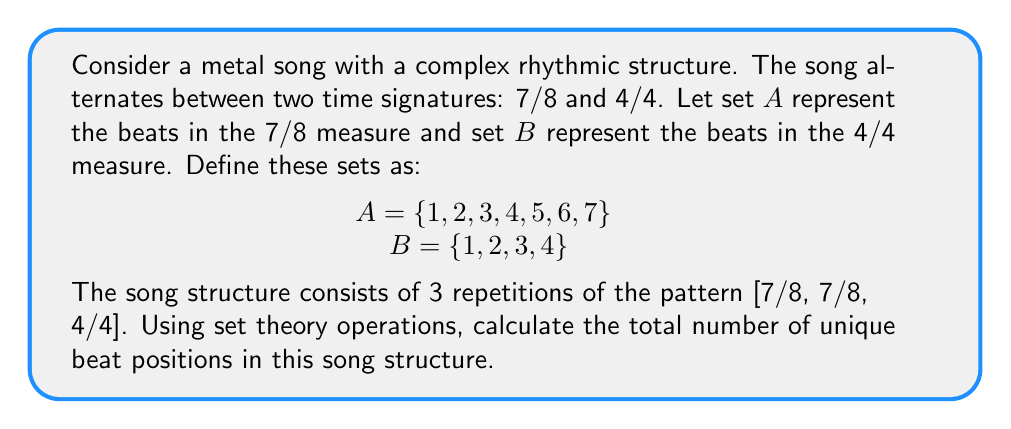Can you answer this question? To solve this problem, we need to follow these steps:

1) First, let's consider the pattern [7/8, 7/8, 4/4]. This can be represented as A ∪ A ∪ B.

2) Since A ∪ A = A (union with itself doesn't add new elements), we can simplify this to A ∪ B.

3) Now, we need to calculate |A ∪ B|, where |X| denotes the cardinality (number of elements) of set X.

4) We can use the formula: |A ∪ B| = |A| + |B| - |A ∩ B|

5) We know:
   |A| = 7
   |B| = 4
   A ∩ B = {1, 2, 3, 4}, so |A ∩ B| = 4

6) Plugging into the formula:
   |A ∪ B| = 7 + 4 - 4 = 7

7) This means there are 7 unique beat positions in one repetition of the pattern.

8) The song structure consists of 3 repetitions of this pattern.

9) Since these repetitions don't add any new unique beat positions, the total number of unique beat positions in the song structure remains 7.
Answer: The total number of unique beat positions in the song structure is 7. 